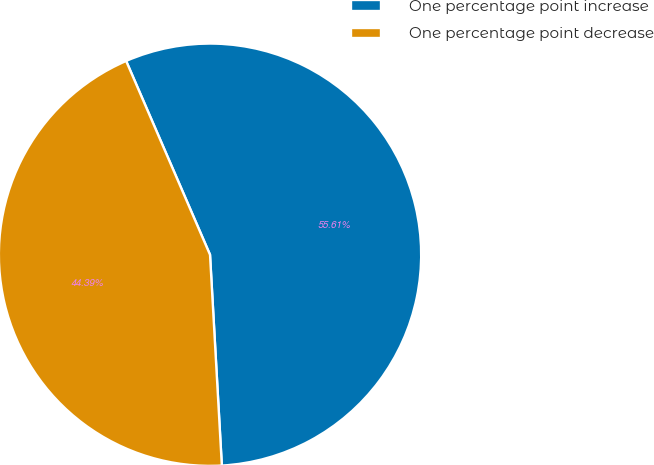Convert chart to OTSL. <chart><loc_0><loc_0><loc_500><loc_500><pie_chart><fcel>One percentage point increase<fcel>One percentage point decrease<nl><fcel>55.61%<fcel>44.39%<nl></chart> 